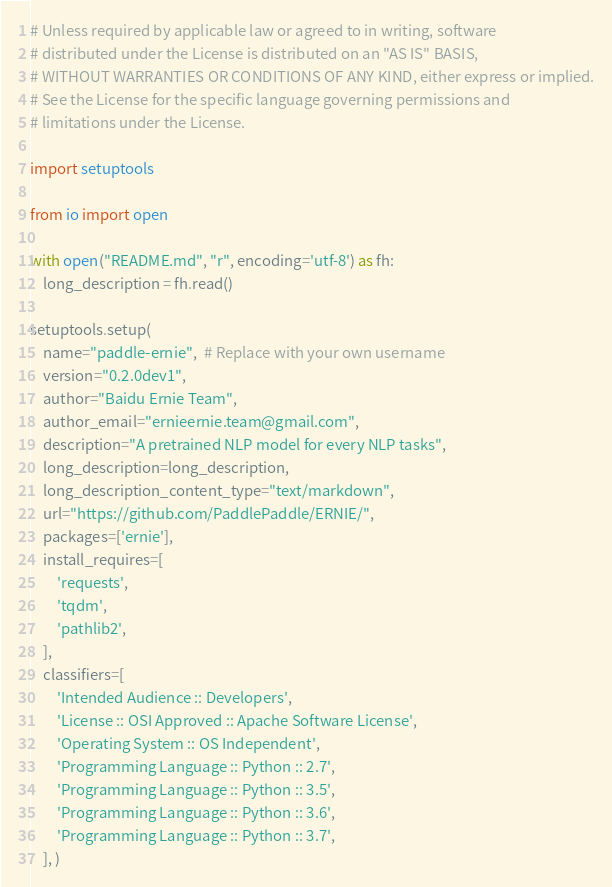Convert code to text. <code><loc_0><loc_0><loc_500><loc_500><_Python_># Unless required by applicable law or agreed to in writing, software
# distributed under the License is distributed on an "AS IS" BASIS,
# WITHOUT WARRANTIES OR CONDITIONS OF ANY KIND, either express or implied.
# See the License for the specific language governing permissions and
# limitations under the License.

import setuptools

from io import open

with open("README.md", "r", encoding='utf-8') as fh:
    long_description = fh.read()

setuptools.setup(
    name="paddle-ernie",  # Replace with your own username
    version="0.2.0dev1",
    author="Baidu Ernie Team",
    author_email="ernieernie.team@gmail.com",
    description="A pretrained NLP model for every NLP tasks",
    long_description=long_description,
    long_description_content_type="text/markdown",
    url="https://github.com/PaddlePaddle/ERNIE/",
    packages=['ernie'],
    install_requires=[
        'requests',
        'tqdm',
        'pathlib2',
    ],
    classifiers=[
        'Intended Audience :: Developers',
        'License :: OSI Approved :: Apache Software License',
        'Operating System :: OS Independent',
        'Programming Language :: Python :: 2.7',
        'Programming Language :: Python :: 3.5',
        'Programming Language :: Python :: 3.6',
        'Programming Language :: Python :: 3.7',
    ], )
</code> 